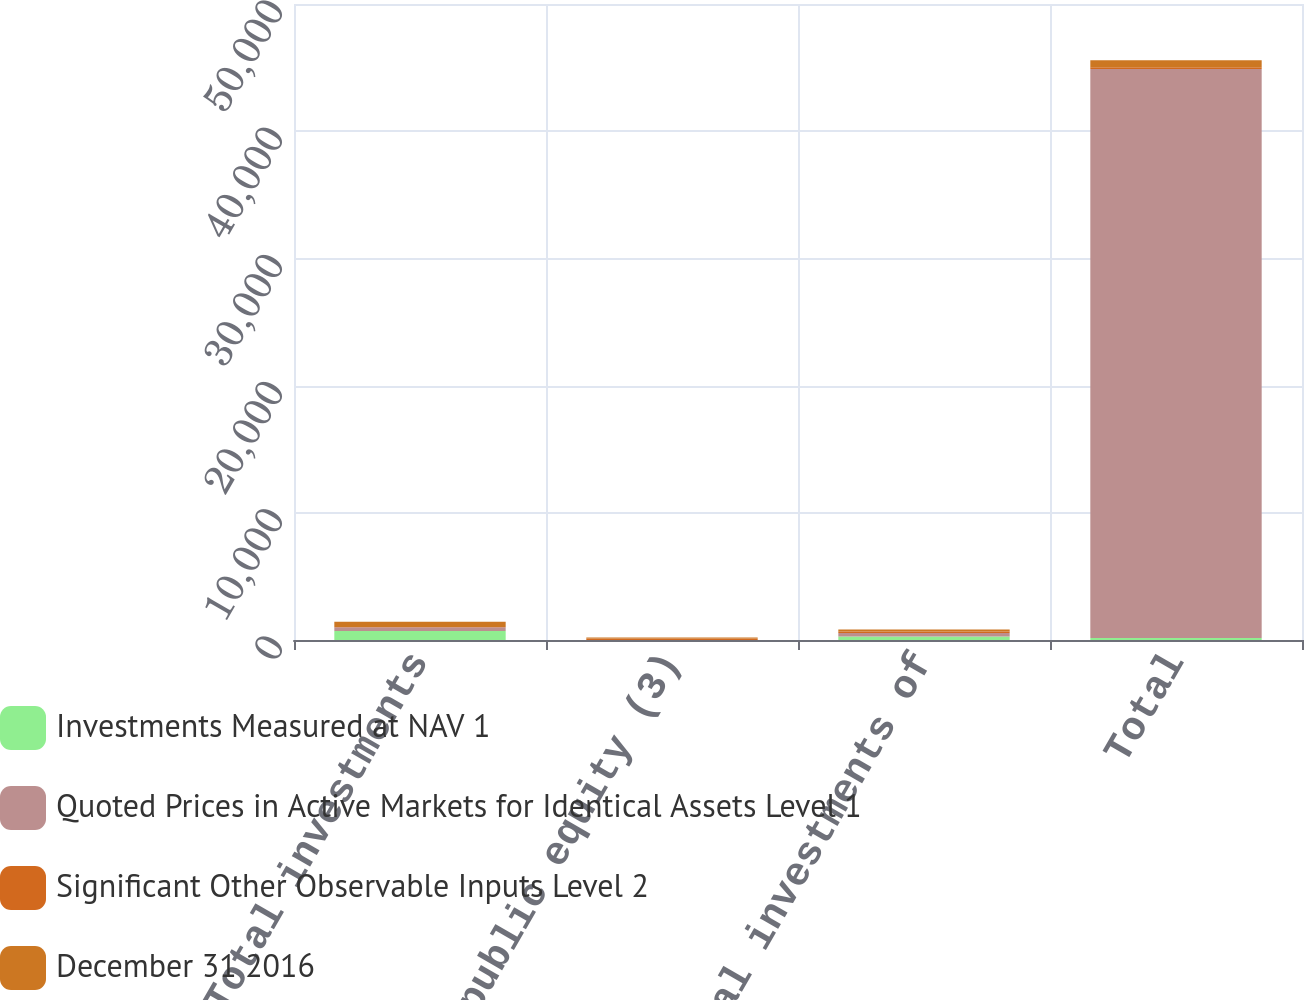<chart> <loc_0><loc_0><loc_500><loc_500><stacked_bar_chart><ecel><fcel>Total investments<fcel>Private / public equity (3)<fcel>Total investments of<fcel>Total<nl><fcel>Investments Measured at NAV 1<fcel>698<fcel>3<fcel>281<fcel>152<nl><fcel>Quoted Prices in Active Markets for Identical Assets Level 1<fcel>299<fcel>2<fcel>276<fcel>44736<nl><fcel>Significant Other Observable Inputs Level 2<fcel>31<fcel>112<fcel>112<fcel>143<nl><fcel>December 31 2016<fcel>399<fcel>89<fcel>152<fcel>551<nl></chart> 